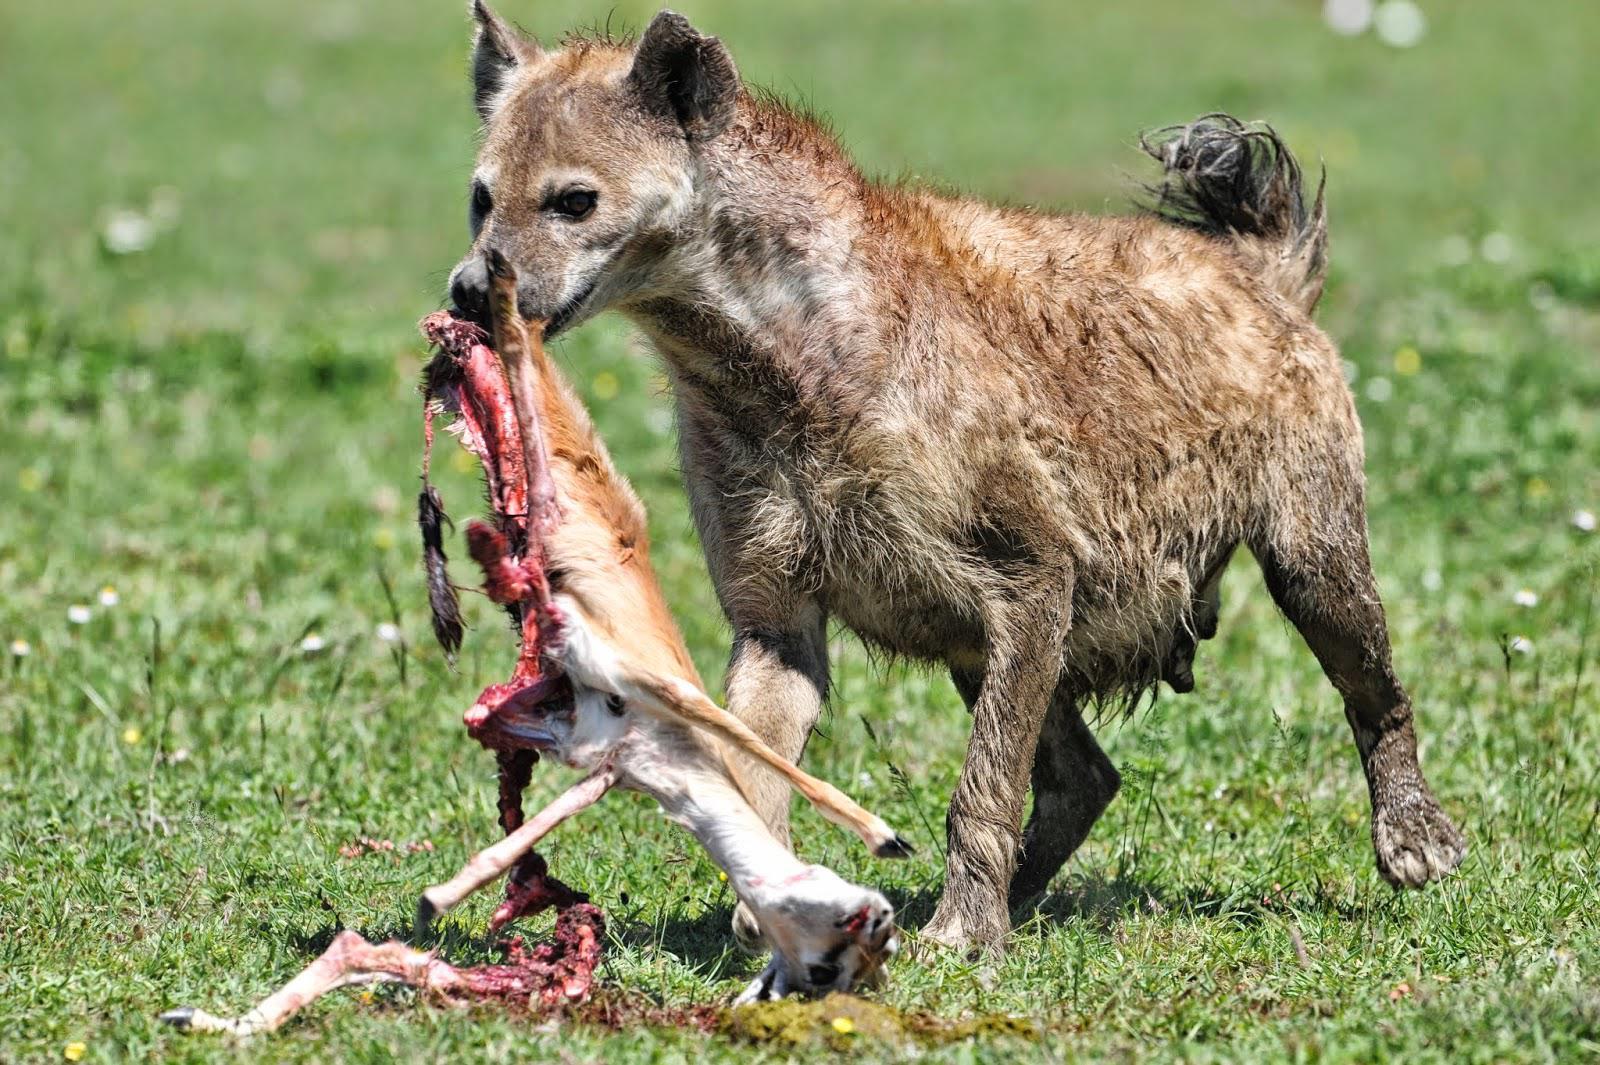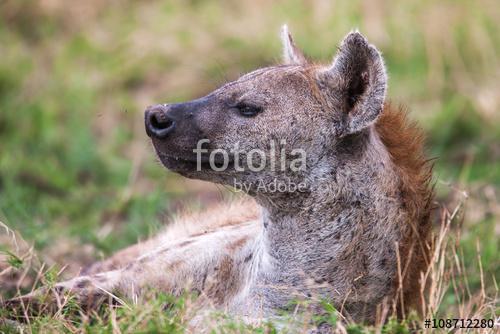The first image is the image on the left, the second image is the image on the right. For the images shown, is this caption "Each image contains multiple hyenas, and one image shows a fang-baring hyena next to one other hyena." true? Answer yes or no. No. The first image is the image on the left, the second image is the image on the right. Considering the images on both sides, is "There are at least two hyenas in each image." valid? Answer yes or no. No. 